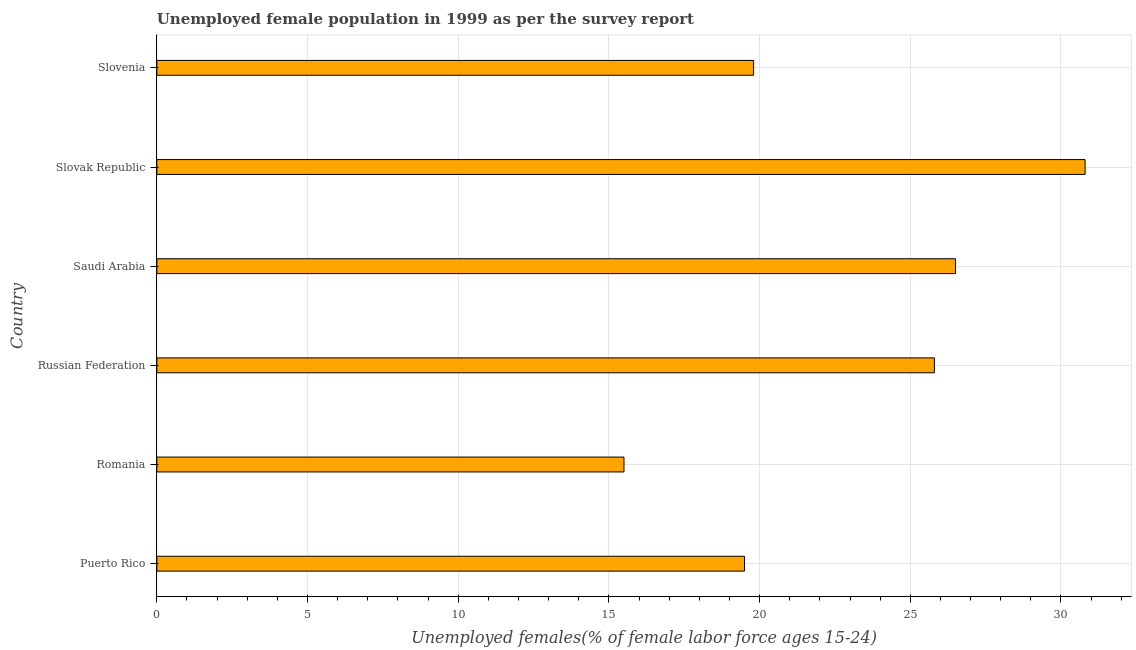What is the title of the graph?
Your answer should be very brief. Unemployed female population in 1999 as per the survey report. What is the label or title of the X-axis?
Provide a succinct answer. Unemployed females(% of female labor force ages 15-24). What is the label or title of the Y-axis?
Offer a terse response. Country. What is the unemployed female youth in Saudi Arabia?
Your response must be concise. 26.5. Across all countries, what is the maximum unemployed female youth?
Provide a short and direct response. 30.8. In which country was the unemployed female youth maximum?
Your response must be concise. Slovak Republic. In which country was the unemployed female youth minimum?
Keep it short and to the point. Romania. What is the sum of the unemployed female youth?
Provide a short and direct response. 137.9. What is the average unemployed female youth per country?
Keep it short and to the point. 22.98. What is the median unemployed female youth?
Offer a very short reply. 22.8. In how many countries, is the unemployed female youth greater than 2 %?
Your answer should be compact. 6. What is the ratio of the unemployed female youth in Russian Federation to that in Slovak Republic?
Keep it short and to the point. 0.84. Is the difference between the unemployed female youth in Romania and Slovak Republic greater than the difference between any two countries?
Your answer should be very brief. Yes. Is the sum of the unemployed female youth in Slovak Republic and Slovenia greater than the maximum unemployed female youth across all countries?
Your response must be concise. Yes. How many countries are there in the graph?
Make the answer very short. 6. What is the Unemployed females(% of female labor force ages 15-24) of Romania?
Make the answer very short. 15.5. What is the Unemployed females(% of female labor force ages 15-24) in Russian Federation?
Offer a terse response. 25.8. What is the Unemployed females(% of female labor force ages 15-24) of Saudi Arabia?
Your answer should be compact. 26.5. What is the Unemployed females(% of female labor force ages 15-24) in Slovak Republic?
Give a very brief answer. 30.8. What is the Unemployed females(% of female labor force ages 15-24) of Slovenia?
Your answer should be compact. 19.8. What is the difference between the Unemployed females(% of female labor force ages 15-24) in Puerto Rico and Russian Federation?
Provide a succinct answer. -6.3. What is the difference between the Unemployed females(% of female labor force ages 15-24) in Puerto Rico and Slovak Republic?
Your answer should be compact. -11.3. What is the difference between the Unemployed females(% of female labor force ages 15-24) in Romania and Slovak Republic?
Keep it short and to the point. -15.3. What is the difference between the Unemployed females(% of female labor force ages 15-24) in Romania and Slovenia?
Provide a succinct answer. -4.3. What is the difference between the Unemployed females(% of female labor force ages 15-24) in Russian Federation and Saudi Arabia?
Keep it short and to the point. -0.7. What is the difference between the Unemployed females(% of female labor force ages 15-24) in Russian Federation and Slovak Republic?
Provide a succinct answer. -5. What is the difference between the Unemployed females(% of female labor force ages 15-24) in Russian Federation and Slovenia?
Make the answer very short. 6. What is the difference between the Unemployed females(% of female labor force ages 15-24) in Saudi Arabia and Slovak Republic?
Your answer should be compact. -4.3. What is the ratio of the Unemployed females(% of female labor force ages 15-24) in Puerto Rico to that in Romania?
Offer a very short reply. 1.26. What is the ratio of the Unemployed females(% of female labor force ages 15-24) in Puerto Rico to that in Russian Federation?
Offer a terse response. 0.76. What is the ratio of the Unemployed females(% of female labor force ages 15-24) in Puerto Rico to that in Saudi Arabia?
Your answer should be very brief. 0.74. What is the ratio of the Unemployed females(% of female labor force ages 15-24) in Puerto Rico to that in Slovak Republic?
Keep it short and to the point. 0.63. What is the ratio of the Unemployed females(% of female labor force ages 15-24) in Puerto Rico to that in Slovenia?
Provide a short and direct response. 0.98. What is the ratio of the Unemployed females(% of female labor force ages 15-24) in Romania to that in Russian Federation?
Your answer should be compact. 0.6. What is the ratio of the Unemployed females(% of female labor force ages 15-24) in Romania to that in Saudi Arabia?
Provide a succinct answer. 0.58. What is the ratio of the Unemployed females(% of female labor force ages 15-24) in Romania to that in Slovak Republic?
Your response must be concise. 0.5. What is the ratio of the Unemployed females(% of female labor force ages 15-24) in Romania to that in Slovenia?
Give a very brief answer. 0.78. What is the ratio of the Unemployed females(% of female labor force ages 15-24) in Russian Federation to that in Saudi Arabia?
Provide a succinct answer. 0.97. What is the ratio of the Unemployed females(% of female labor force ages 15-24) in Russian Federation to that in Slovak Republic?
Ensure brevity in your answer.  0.84. What is the ratio of the Unemployed females(% of female labor force ages 15-24) in Russian Federation to that in Slovenia?
Offer a terse response. 1.3. What is the ratio of the Unemployed females(% of female labor force ages 15-24) in Saudi Arabia to that in Slovak Republic?
Offer a very short reply. 0.86. What is the ratio of the Unemployed females(% of female labor force ages 15-24) in Saudi Arabia to that in Slovenia?
Your answer should be compact. 1.34. What is the ratio of the Unemployed females(% of female labor force ages 15-24) in Slovak Republic to that in Slovenia?
Your answer should be compact. 1.56. 